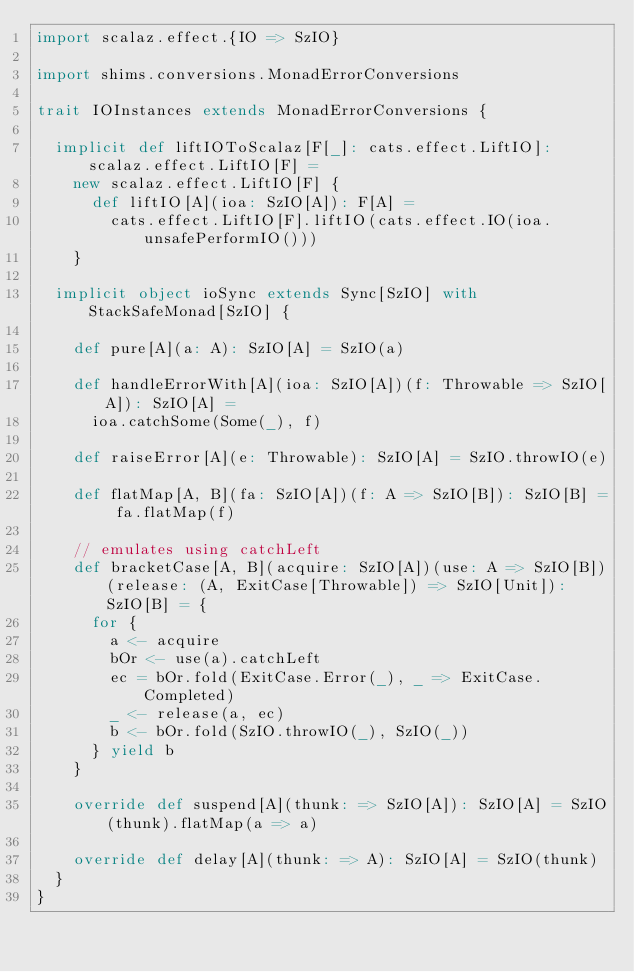Convert code to text. <code><loc_0><loc_0><loc_500><loc_500><_Scala_>import scalaz.effect.{IO => SzIO}

import shims.conversions.MonadErrorConversions

trait IOInstances extends MonadErrorConversions {

  implicit def liftIOToScalaz[F[_]: cats.effect.LiftIO]: scalaz.effect.LiftIO[F] =
    new scalaz.effect.LiftIO[F] {
      def liftIO[A](ioa: SzIO[A]): F[A] =
        cats.effect.LiftIO[F].liftIO(cats.effect.IO(ioa.unsafePerformIO()))
    }

  implicit object ioSync extends Sync[SzIO] with StackSafeMonad[SzIO] {

    def pure[A](a: A): SzIO[A] = SzIO(a)

    def handleErrorWith[A](ioa: SzIO[A])(f: Throwable => SzIO[A]): SzIO[A] =
      ioa.catchSome(Some(_), f)

    def raiseError[A](e: Throwable): SzIO[A] = SzIO.throwIO(e)

    def flatMap[A, B](fa: SzIO[A])(f: A => SzIO[B]): SzIO[B] = fa.flatMap(f)

    // emulates using catchLeft
    def bracketCase[A, B](acquire: SzIO[A])(use: A => SzIO[B])(release: (A, ExitCase[Throwable]) => SzIO[Unit]): SzIO[B] = {
      for {
        a <- acquire
        bOr <- use(a).catchLeft
        ec = bOr.fold(ExitCase.Error(_), _ => ExitCase.Completed)
        _ <- release(a, ec)
        b <- bOr.fold(SzIO.throwIO(_), SzIO(_))
      } yield b
    }

    override def suspend[A](thunk: => SzIO[A]): SzIO[A] = SzIO(thunk).flatMap(a => a)

    override def delay[A](thunk: => A): SzIO[A] = SzIO(thunk)
  }
}
</code> 